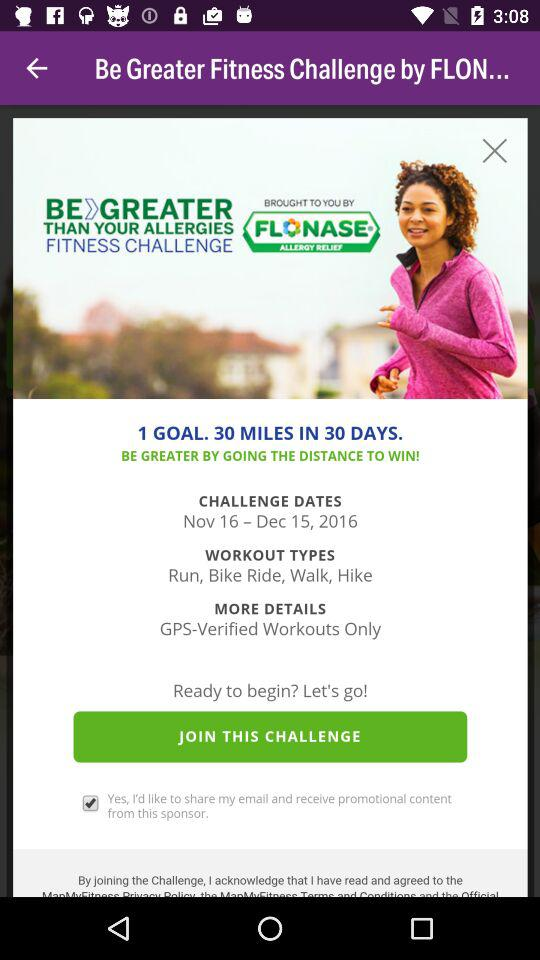How many different types of workouts are available?
Answer the question using a single word or phrase. 4 